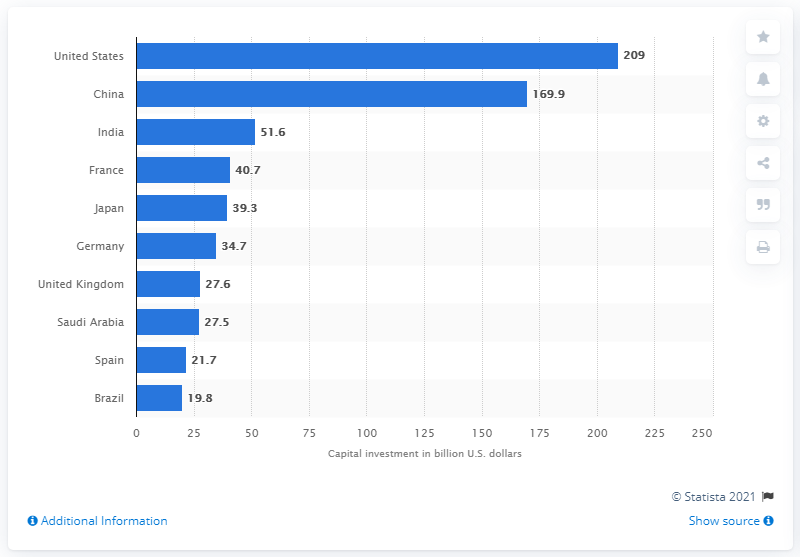Specify some key components in this picture. According to estimates for 2019, China had the highest direct contribution to GDP among all countries. Investors in the United States invested a significant amount, approximately 209, in the travel and tourism industry in 2019. 